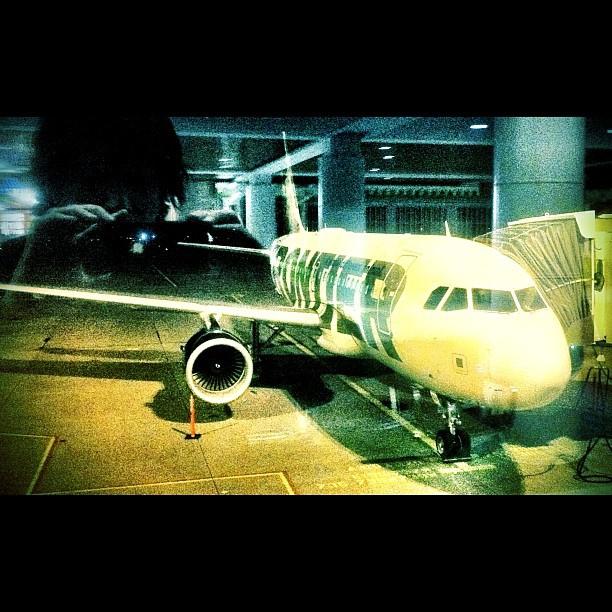Is the airplane flying?
Give a very brief answer. No. Are the engines on?
Write a very short answer. No. Is the landing gear down?
Quick response, please. Yes. 